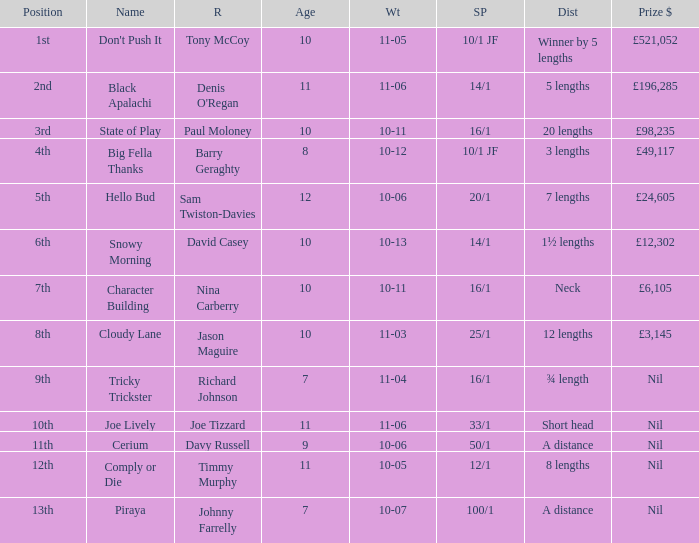Can you parse all the data within this table? {'header': ['Position', 'Name', 'R', 'Age', 'Wt', 'SP', 'Dist', 'Prize $'], 'rows': [['1st', "Don't Push It", 'Tony McCoy', '10', '11-05', '10/1 JF', 'Winner by 5 lengths', '£521,052'], ['2nd', 'Black Apalachi', "Denis O'Regan", '11', '11-06', '14/1', '5 lengths', '£196,285'], ['3rd', 'State of Play', 'Paul Moloney', '10', '10-11', '16/1', '20 lengths', '£98,235'], ['4th', 'Big Fella Thanks', 'Barry Geraghty', '8', '10-12', '10/1 JF', '3 lengths', '£49,117'], ['5th', 'Hello Bud', 'Sam Twiston-Davies', '12', '10-06', '20/1', '7 lengths', '£24,605'], ['6th', 'Snowy Morning', 'David Casey', '10', '10-13', '14/1', '1½ lengths', '£12,302'], ['7th', 'Character Building', 'Nina Carberry', '10', '10-11', '16/1', 'Neck', '£6,105'], ['8th', 'Cloudy Lane', 'Jason Maguire', '10', '11-03', '25/1', '12 lengths', '£3,145'], ['9th', 'Tricky Trickster', 'Richard Johnson', '7', '11-04', '16/1', '¾ length', 'Nil'], ['10th', 'Joe Lively', 'Joe Tizzard', '11', '11-06', '33/1', 'Short head', 'Nil'], ['11th', 'Cerium', 'Davy Russell', '9', '10-06', '50/1', 'A distance', 'Nil'], ['12th', 'Comply or Die', 'Timmy Murphy', '11', '10-05', '12/1', '8 lengths', 'Nil'], ['13th', 'Piraya', 'Johnny Farrelly', '7', '10-07', '100/1', 'A distance', 'Nil']]}  How much did Nina Carberry win?  £6,105. 